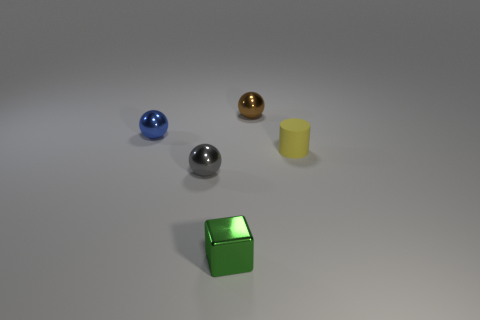Subtract all brown balls. How many balls are left? 2 Add 2 tiny yellow matte objects. How many objects exist? 7 Subtract 1 balls. How many balls are left? 2 Subtract all cylinders. How many objects are left? 4 Subtract all yellow spheres. Subtract all purple blocks. How many spheres are left? 3 Add 5 tiny brown metal things. How many tiny brown metal things exist? 6 Subtract 0 red spheres. How many objects are left? 5 Subtract all red shiny spheres. Subtract all tiny green blocks. How many objects are left? 4 Add 4 small metal cubes. How many small metal cubes are left? 5 